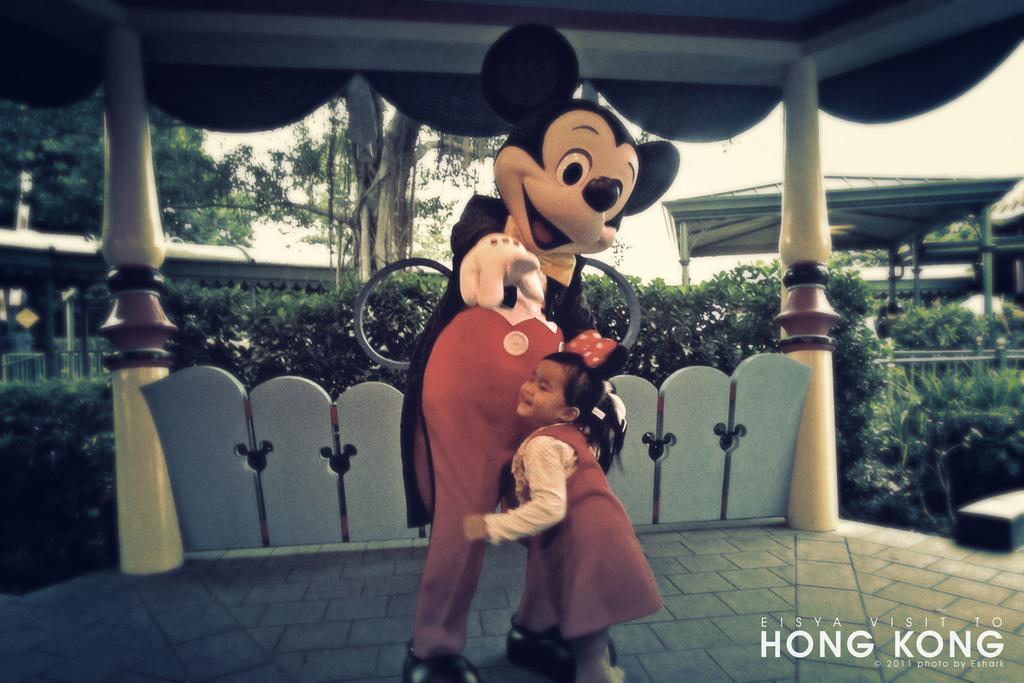Who is present in the image? There is a girl in the image. What is the girl standing near? The girl is standing near a Mickey Mouse. What can be seen in the background of the image? There are pillars, bushes, trees, tents, and the sky visible in the background of the image. Can you describe the watermark in the image? There is a watermark in the right bottom corner of the image. What type of silk fabric is draped over the tents in the image? There is no silk fabric present in the image; it only shows tents in the background. What time is it according to the clocks in the image? There are no clocks visible in the image. 